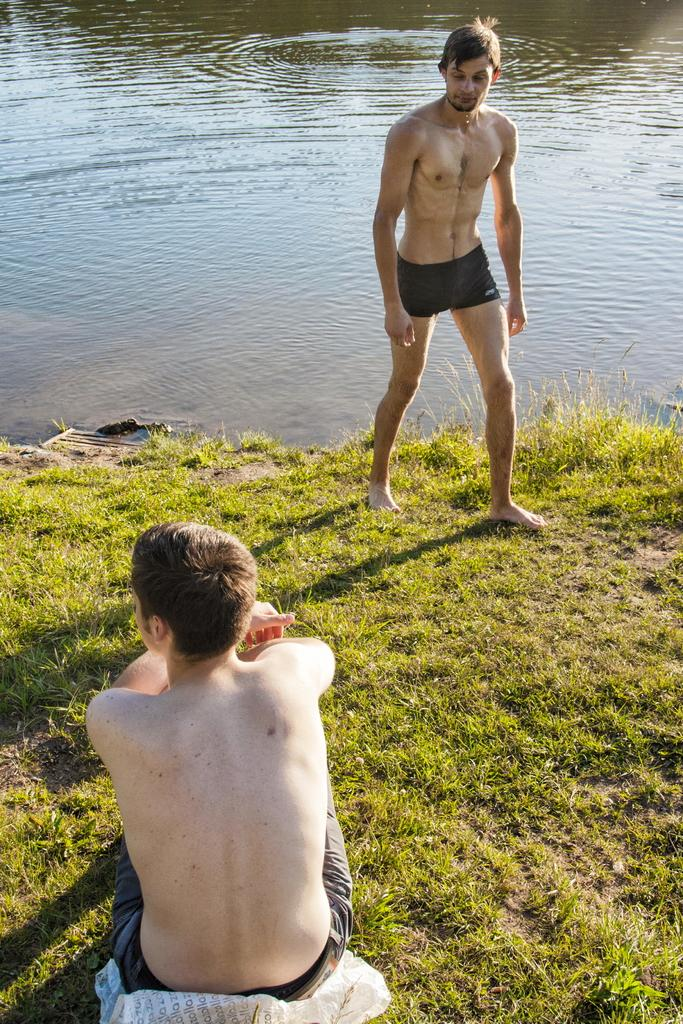What is happening in the foreground of the image? There is a person sitting in the foreground. What is happening in the background of the image? There is a water body in the background. What is the other person in the image doing? There is a person walking in the image. What type of jar can be seen floating on the water body in the image? There is no jar present in the image; it only features a person sitting, a person walking, and a water body in the background. What type of vessel is the person walking on in the image? The person is walking on solid ground, not on a vessel, as there is no indication of a vessel in the image. 